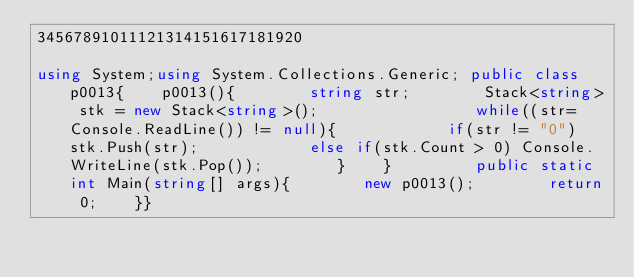<code> <loc_0><loc_0><loc_500><loc_500><_C#_>34567891011121314151617181920 

using System;using System.Collections.Generic; public class p0013{    p0013(){        string str;        Stack<string> stk = new Stack<string>();                 while((str=Console.ReadLine()) != null){            if(str != "0") stk.Push(str);            else if(stk.Count > 0) Console.WriteLine(stk.Pop());        }    }         public static int Main(string[] args){        new p0013();        return 0;    }} </code> 